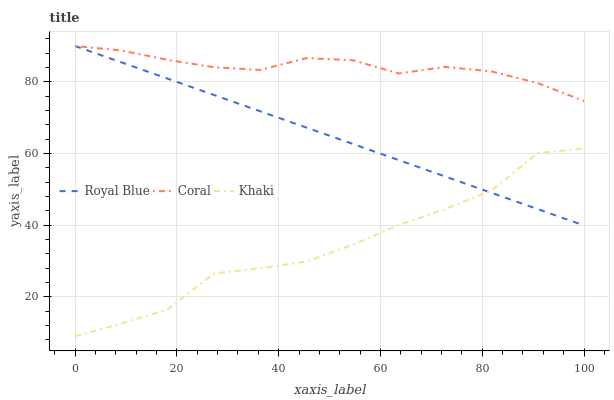Does Khaki have the minimum area under the curve?
Answer yes or no. Yes. Does Coral have the maximum area under the curve?
Answer yes or no. Yes. Does Coral have the minimum area under the curve?
Answer yes or no. No. Does Khaki have the maximum area under the curve?
Answer yes or no. No. Is Royal Blue the smoothest?
Answer yes or no. Yes. Is Khaki the roughest?
Answer yes or no. Yes. Is Coral the smoothest?
Answer yes or no. No. Is Coral the roughest?
Answer yes or no. No. Does Coral have the lowest value?
Answer yes or no. No. Does Khaki have the highest value?
Answer yes or no. No. Is Khaki less than Coral?
Answer yes or no. Yes. Is Coral greater than Khaki?
Answer yes or no. Yes. Does Khaki intersect Coral?
Answer yes or no. No. 